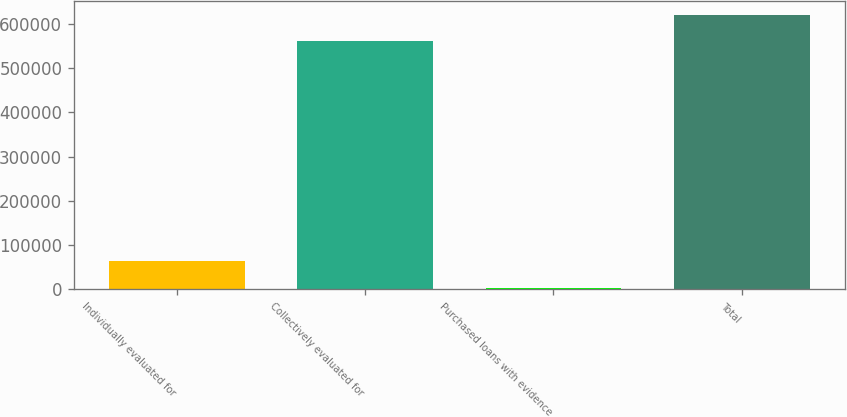<chart> <loc_0><loc_0><loc_500><loc_500><bar_chart><fcel>Individually evaluated for<fcel>Collectively evaluated for<fcel>Purchased loans with evidence<fcel>Total<nl><fcel>62986.3<fcel>560150<fcel>2800<fcel>620336<nl></chart> 